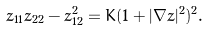<formula> <loc_0><loc_0><loc_500><loc_500>z _ { 1 1 } z _ { 2 2 } - z _ { 1 2 } ^ { 2 } = K ( 1 + | \nabla z | ^ { 2 } ) ^ { 2 } .</formula> 